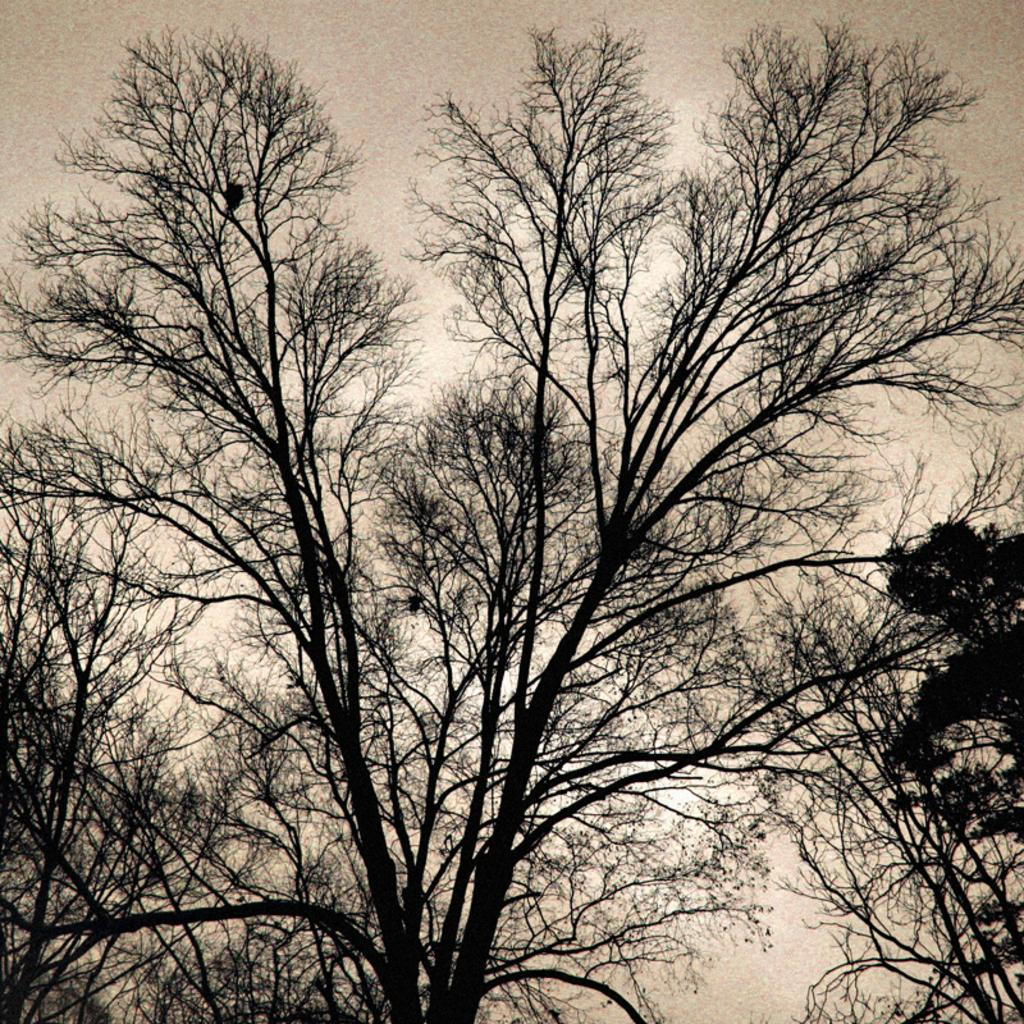What type of vegetation is present in the image? There is a group of trees in the image. What else can be seen in the image besides the trees? The sky is visible in the image. Can you describe the sky in the image? The sky appears to be cloudy. What type of soap is being used to clean the toys in the image? There are no toys or soap present in the image. Can you describe the interaction between the friend and the trees in the image? There is no friend present in the image; it only features a group of trees and a cloudy sky. 